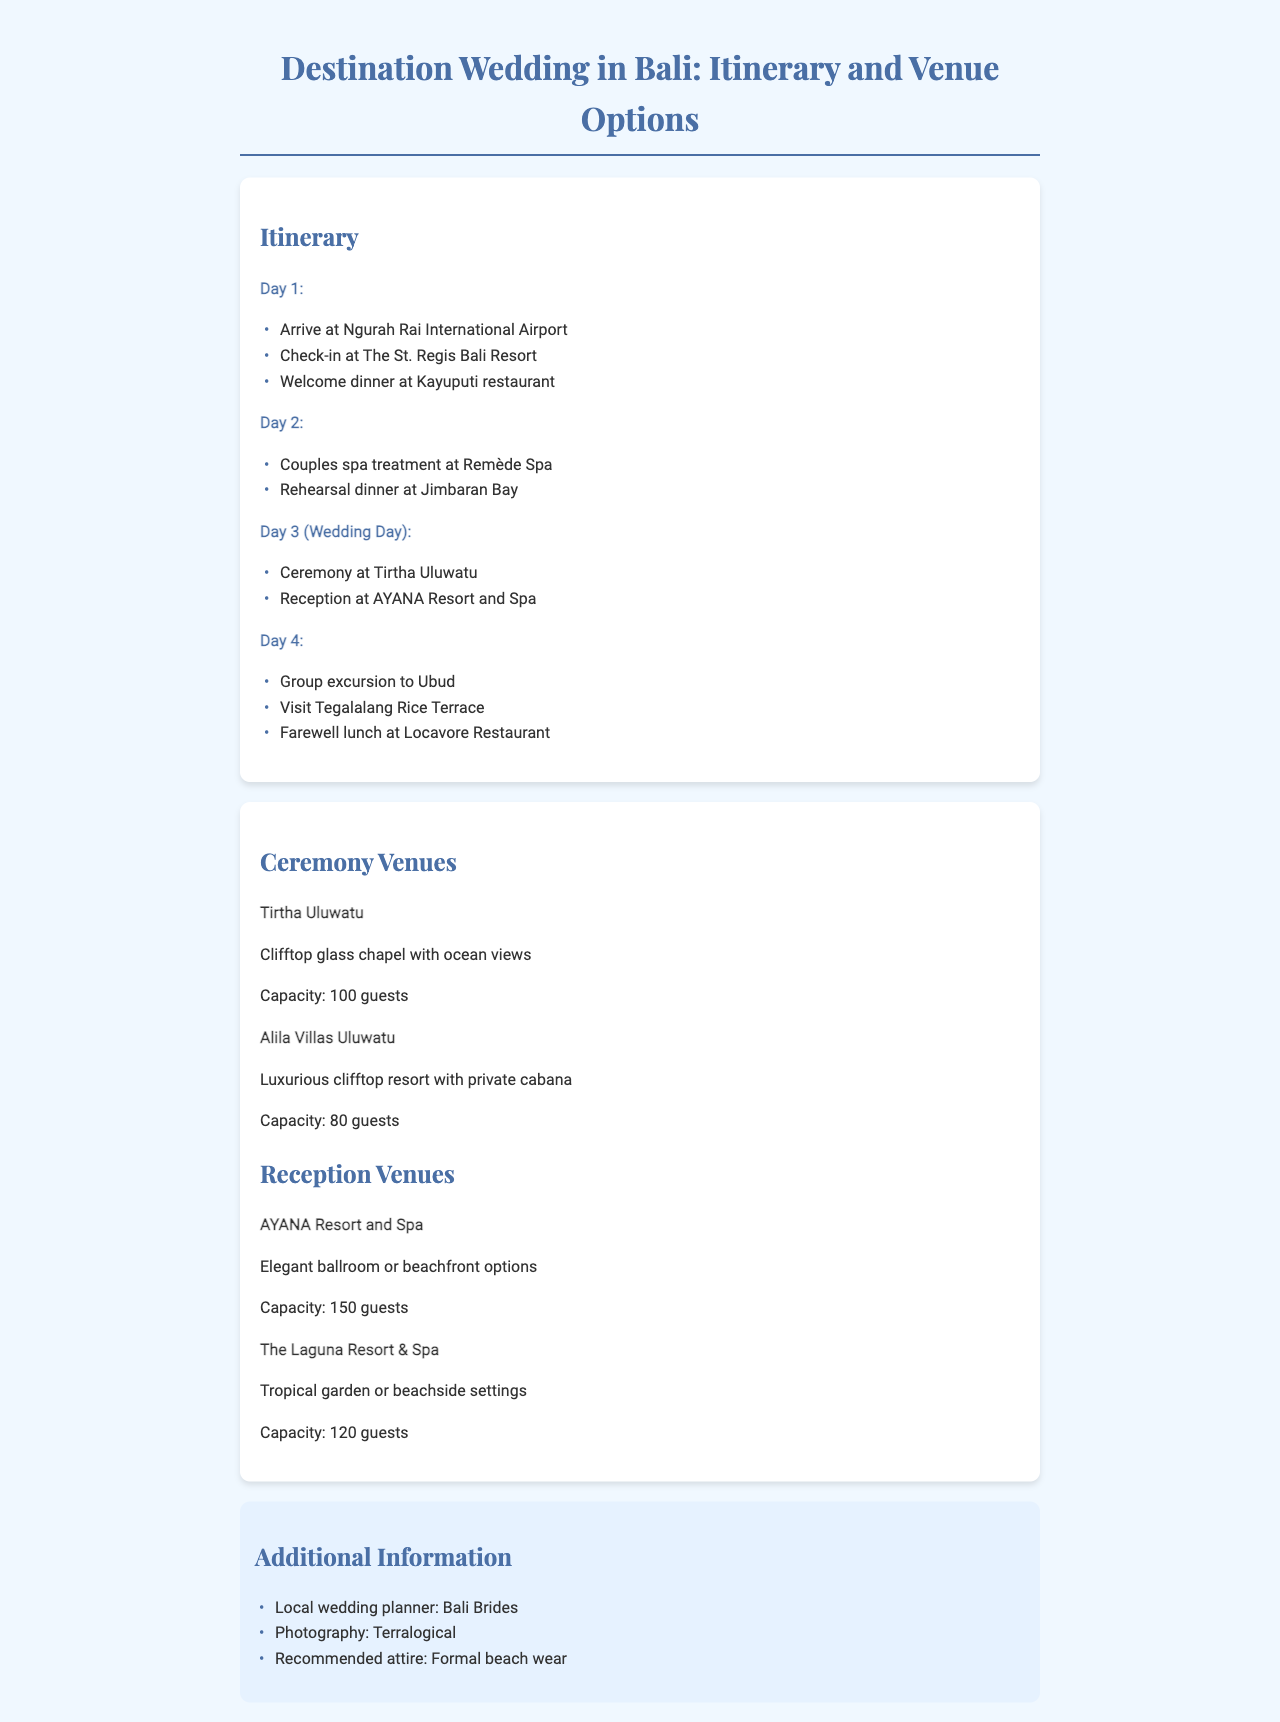What is the arrival airport? The arrival airport mentioned in the document is Ngurah Rai International Airport.
Answer: Ngurah Rai International Airport What is the name of the resort where the guest will check-in? The document states that guests will check in at The St. Regis Bali Resort.
Answer: The St. Regis Bali Resort What is the capacity of Tirtha Uluwatu? The document lists the capacity of Tirtha Uluwatu as 100 guests.
Answer: 100 guests What type of venue is AYANA Resort and Spa? The document describes AYANA Resort and Spa as having elegant ballroom or beachfront options.
Answer: Elegant ballroom or beachfront options Which day is the wedding ceremony scheduled? According to the document, the wedding ceremony is scheduled for Day 3.
Answer: Day 3 How many guests can Alila Villas Uluwatu accommodate? The document states that Alila Villas Uluwatu can accommodate 80 guests.
Answer: 80 guests What unique feature does the ceremony venue Tirtha Uluwatu have? The document mentions that Tirtha Uluwatu has a clifftop glass chapel with ocean views.
Answer: Clifftop glass chapel with ocean views What is the additional service mentioned for wedding planning? The document references Bali Brides as the local wedding planner.
Answer: Bali Brides What is the recommended attire for the wedding? The recommended attire according to the document is formal beach wear.
Answer: Formal beach wear 